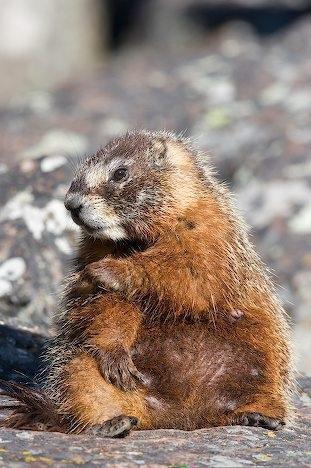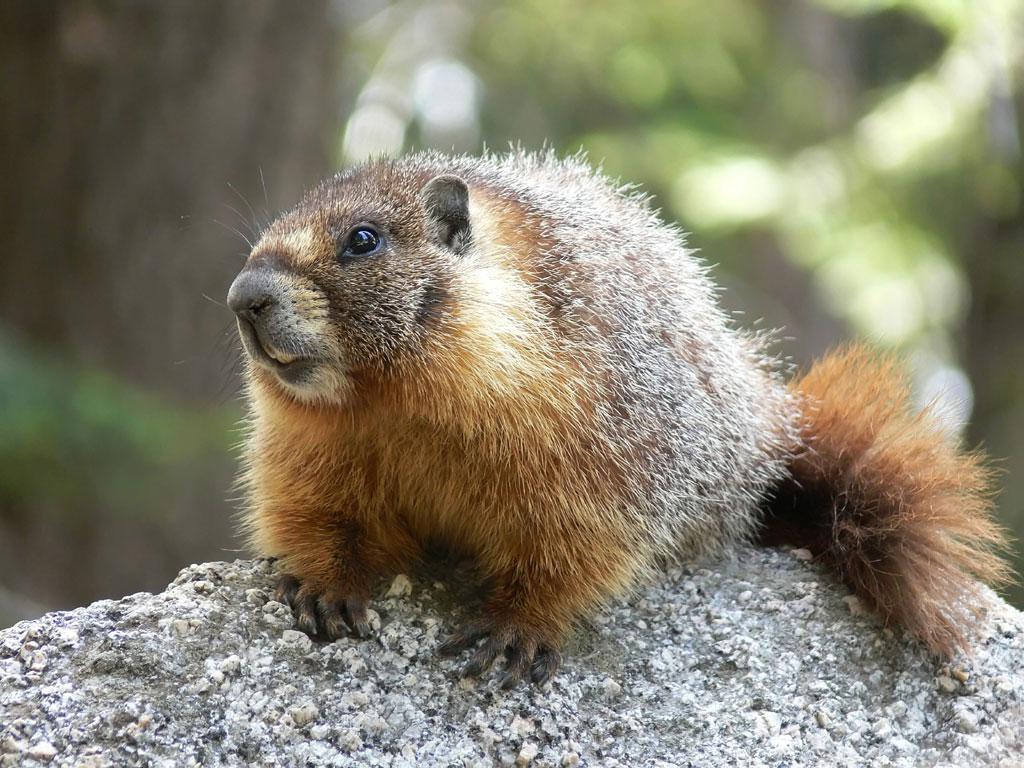The first image is the image on the left, the second image is the image on the right. Evaluate the accuracy of this statement regarding the images: "At least one image contains two animals.". Is it true? Answer yes or no. No. 